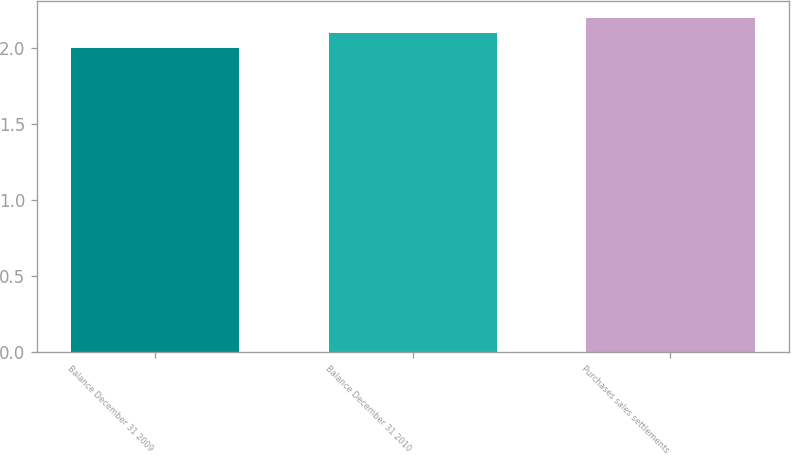Convert chart. <chart><loc_0><loc_0><loc_500><loc_500><bar_chart><fcel>Balance December 31 2009<fcel>Balance December 31 2010<fcel>Purchases sales settlements<nl><fcel>2<fcel>2.1<fcel>2.2<nl></chart> 